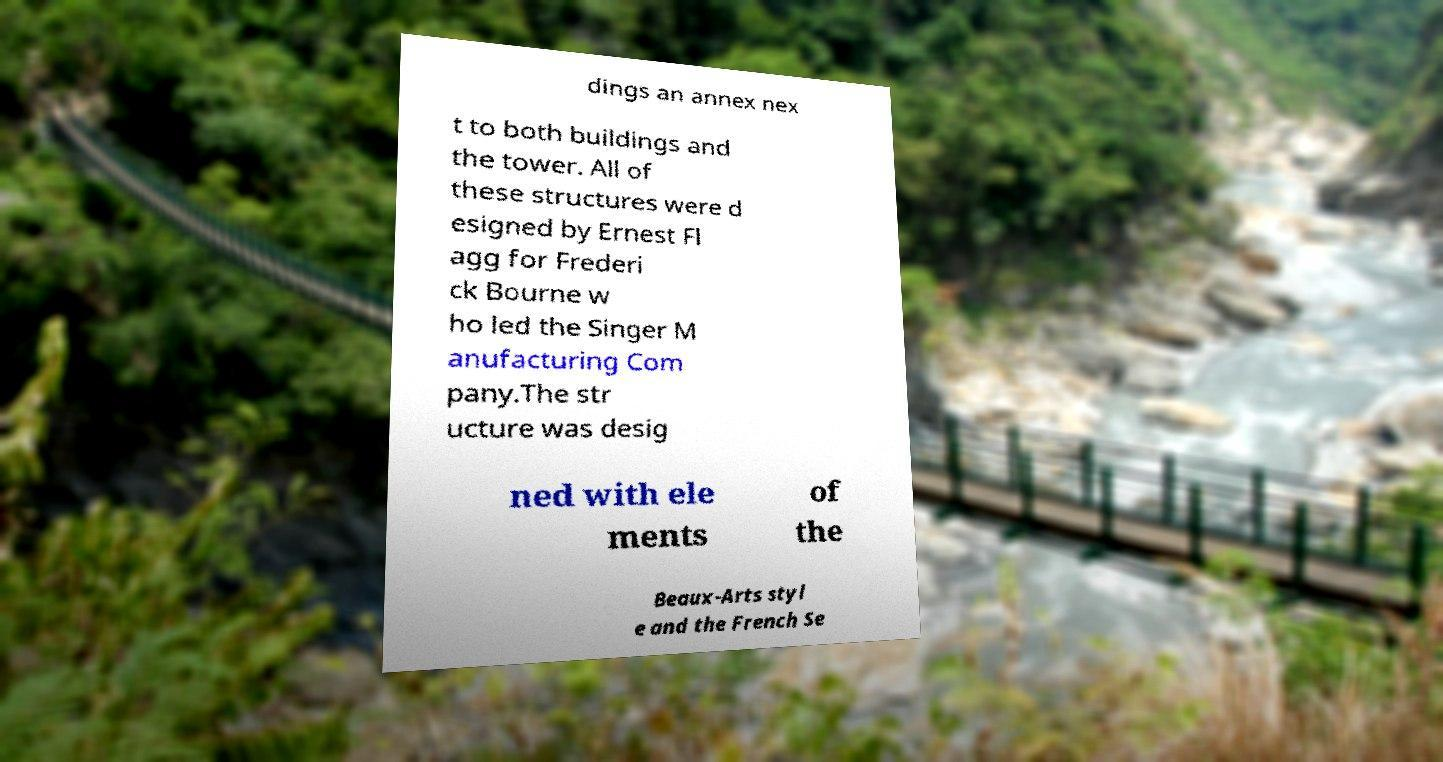Can you accurately transcribe the text from the provided image for me? dings an annex nex t to both buildings and the tower. All of these structures were d esigned by Ernest Fl agg for Frederi ck Bourne w ho led the Singer M anufacturing Com pany.The str ucture was desig ned with ele ments of the Beaux-Arts styl e and the French Se 